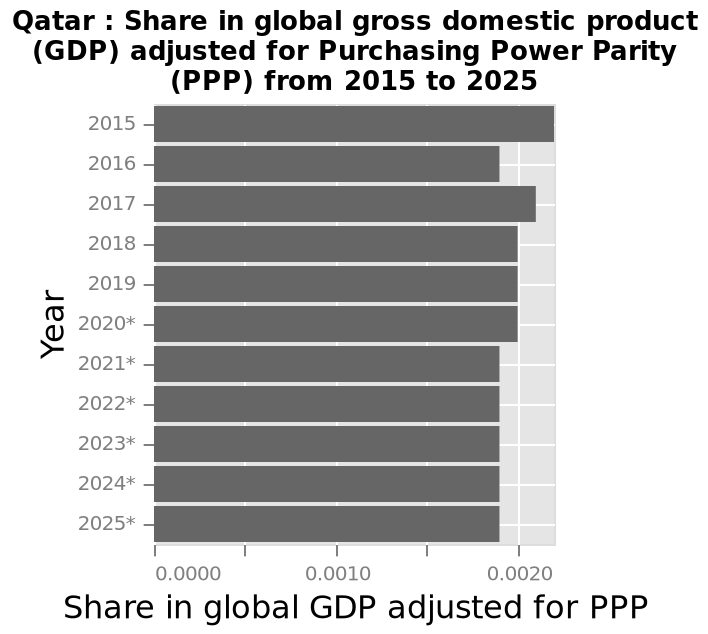<image>
Will the share in global gross domestic product for Qatar decrease or increase from 2021 to 2025? The share in global gross domestic product for Qatar will remain the same, less than 0.0020 from 2021 to 2025. What is measured along the y-axis of the bar chart? The y-axis of the bar chart measures the Year, with 2015 on one end and 2025* at the other. Offer a thorough analysis of the image. The highest share in global gross domestic product for Qatar was in 2025, more than 0.0020. The share has declined since 2015. The share from 2021 to 2025 will be the same, less than 0.0020. 